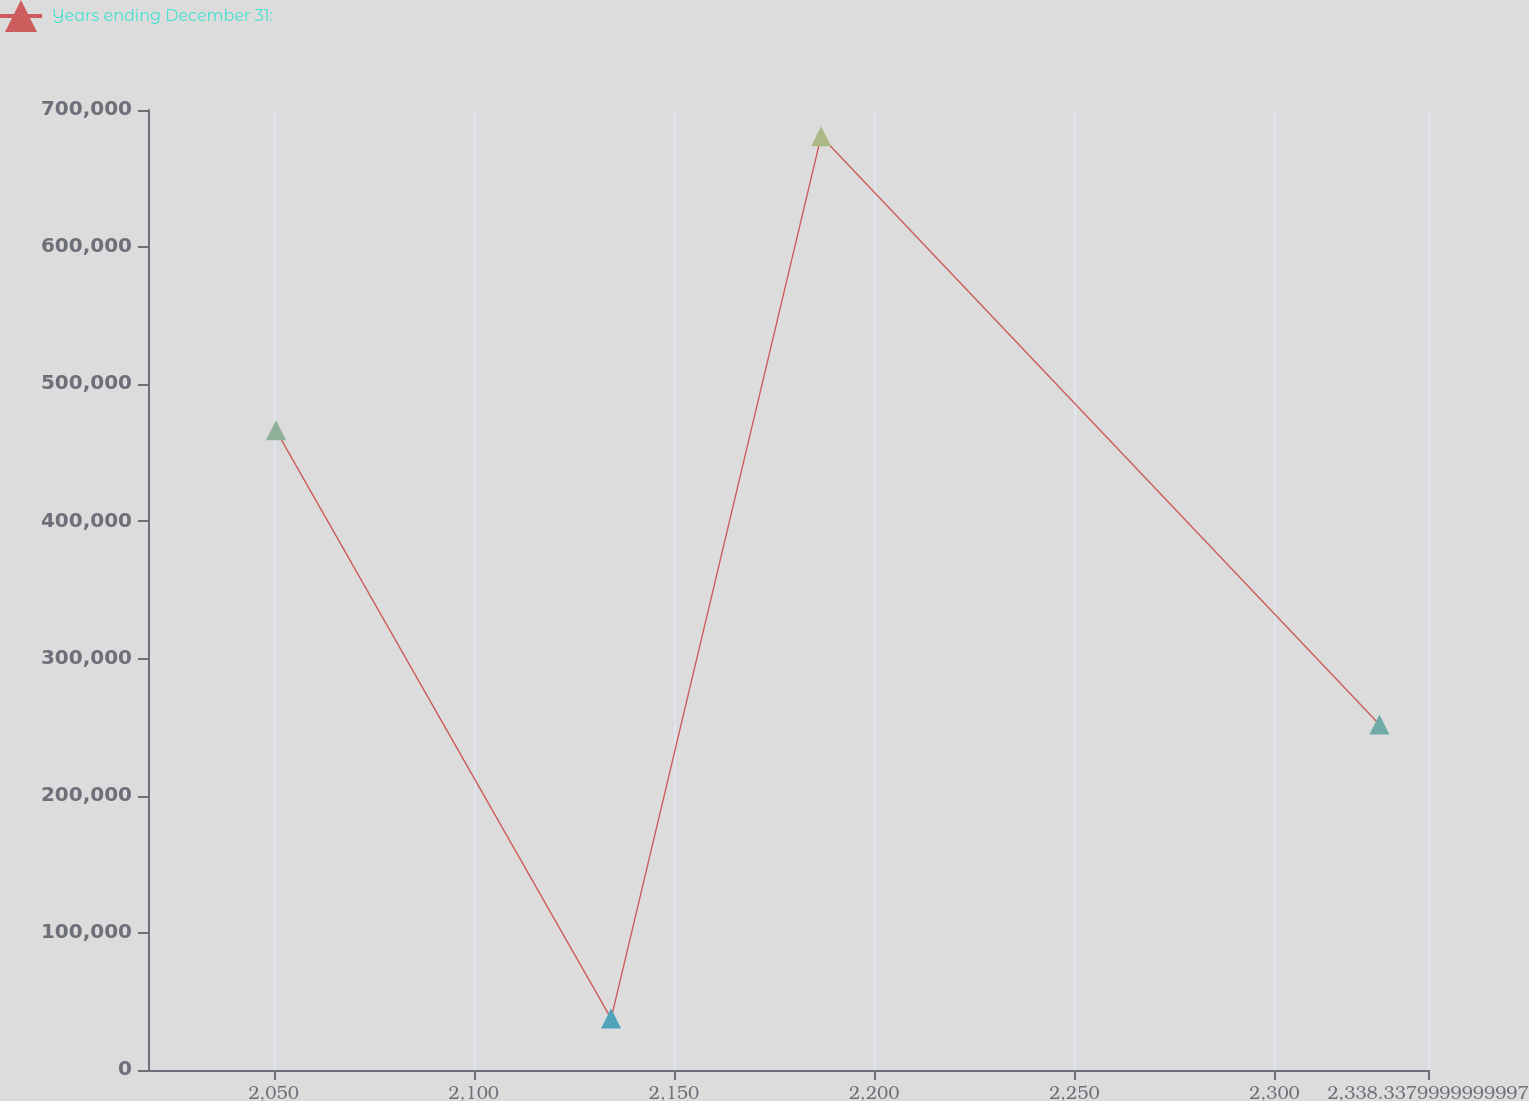Convert chart to OTSL. <chart><loc_0><loc_0><loc_500><loc_500><line_chart><ecel><fcel>Years ending December 31:<nl><fcel>2050.59<fcel>466450<nl><fcel>2134.29<fcel>37514.2<nl><fcel>2186.75<fcel>680918<nl><fcel>2326.21<fcel>251982<nl><fcel>2370.31<fcel>2.18219e+06<nl></chart> 